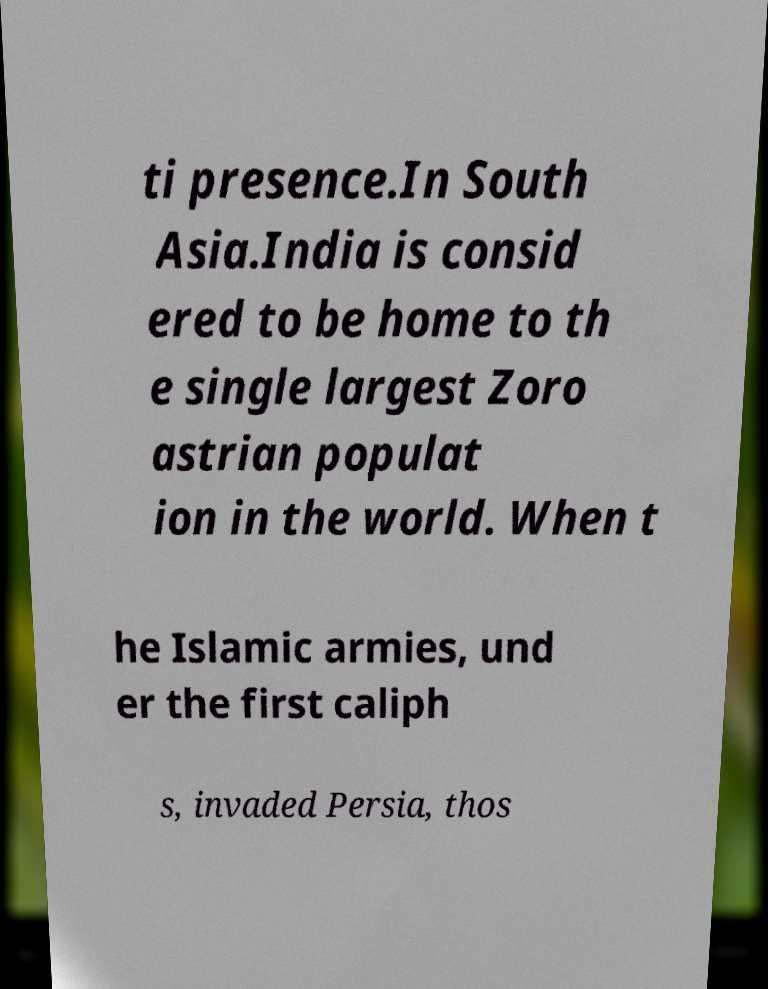I need the written content from this picture converted into text. Can you do that? ti presence.In South Asia.India is consid ered to be home to th e single largest Zoro astrian populat ion in the world. When t he Islamic armies, und er the first caliph s, invaded Persia, thos 